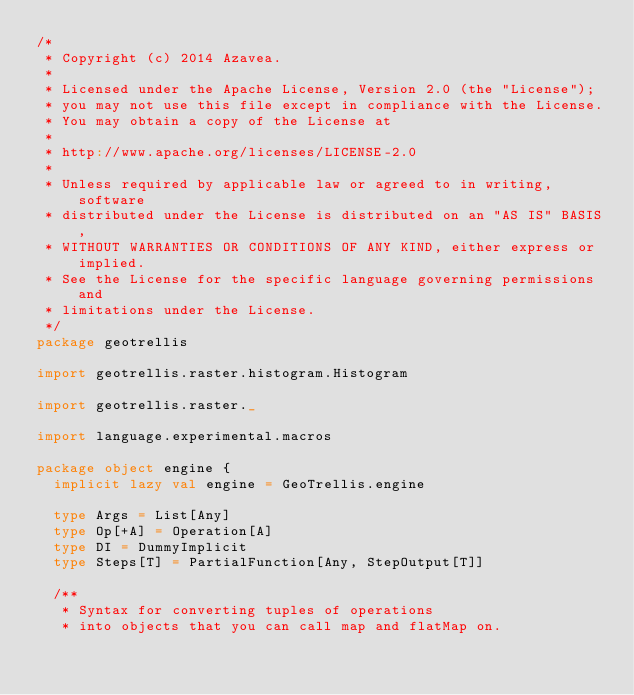Convert code to text. <code><loc_0><loc_0><loc_500><loc_500><_Scala_>/*
 * Copyright (c) 2014 Azavea.
 *
 * Licensed under the Apache License, Version 2.0 (the "License");
 * you may not use this file except in compliance with the License.
 * You may obtain a copy of the License at
 *
 * http://www.apache.org/licenses/LICENSE-2.0
 *
 * Unless required by applicable law or agreed to in writing, software
 * distributed under the License is distributed on an "AS IS" BASIS,
 * WITHOUT WARRANTIES OR CONDITIONS OF ANY KIND, either express or implied.
 * See the License for the specific language governing permissions and
 * limitations under the License.
 */
package geotrellis

import geotrellis.raster.histogram.Histogram

import geotrellis.raster._

import language.experimental.macros

package object engine {
  implicit lazy val engine = GeoTrellis.engine

  type Args = List[Any]
  type Op[+A] = Operation[A]
  type DI = DummyImplicit
  type Steps[T] = PartialFunction[Any, StepOutput[T]]

  /**
   * Syntax for converting tuples of operations
   * into objects that you can call map and flatMap on.</code> 